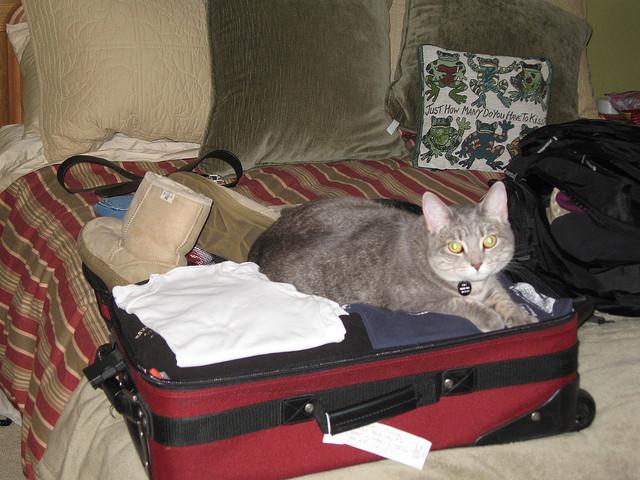Is the suitcase full?
Quick response, please. Yes. What kind of boots is behind the cat?
Be succinct. Uggs. Is the kitty going on vacation?
Answer briefly. Yes. 